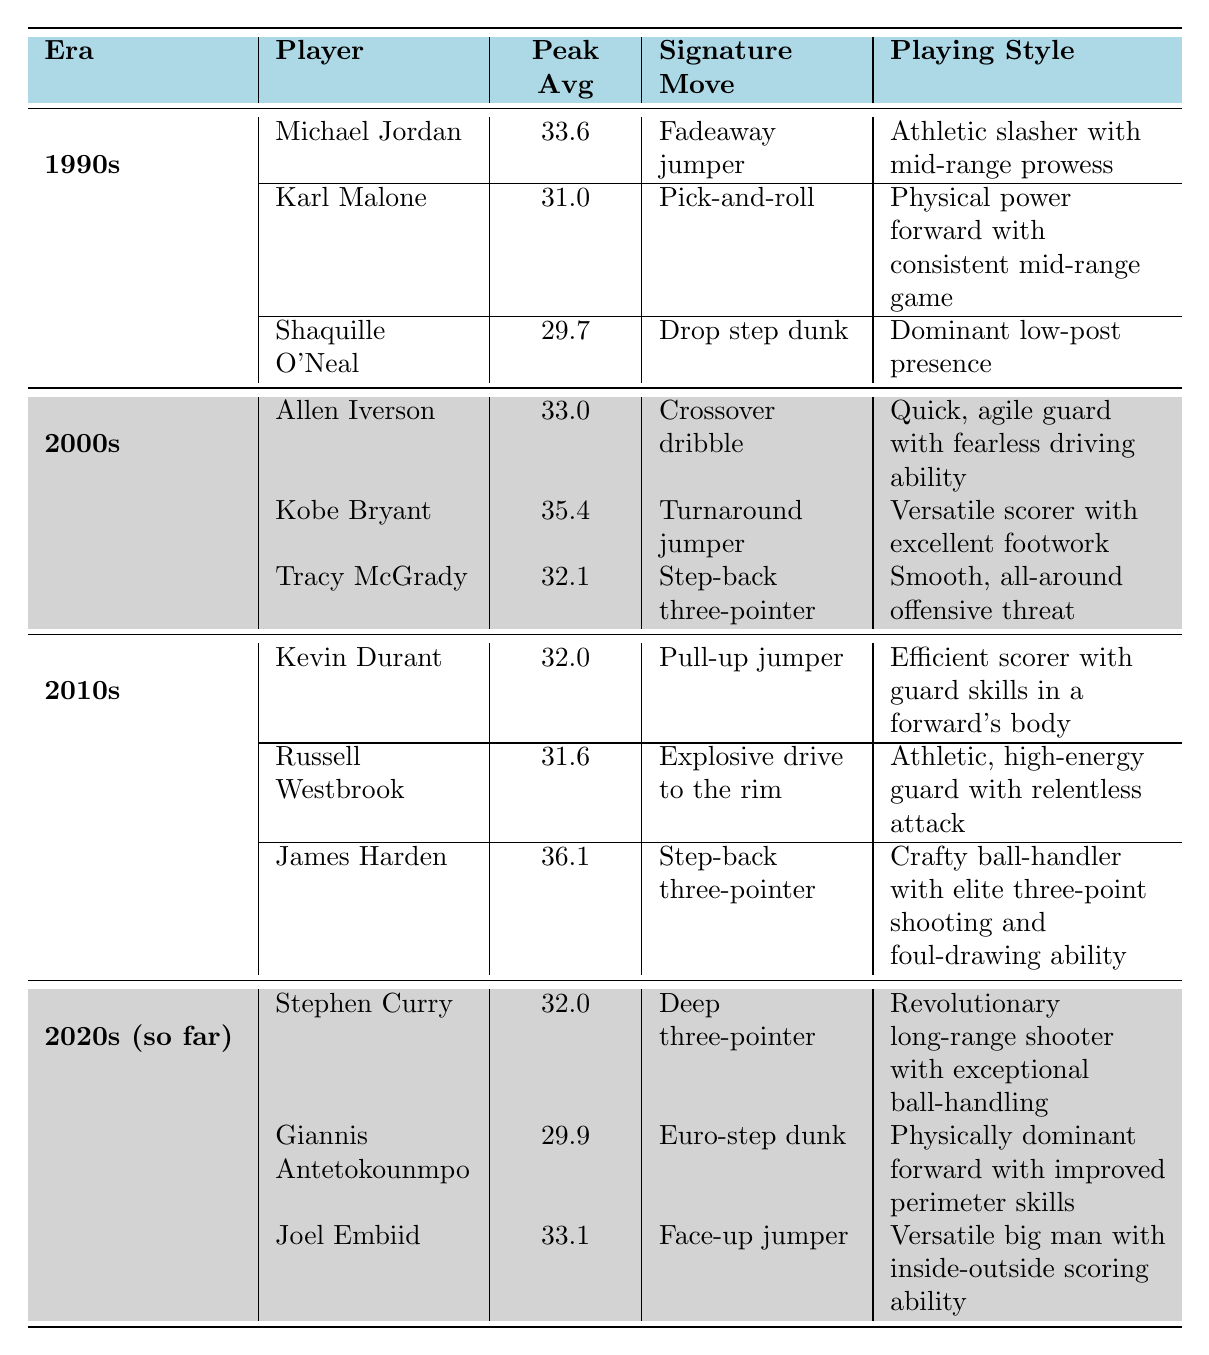What player had the highest peak scoring average in the 2000s? In the 2000s, the peak scoring averages of the top scorers are Allen Iverson (33.0), Kobe Bryant (35.4), and Tracy McGrady (32.1). The highest among these is Kobe Bryant with 35.4.
Answer: 35.4 Which player is known for the "Fadeaway jumper"? The "Fadeaway jumper" is a signature move associated with Michael Jordan, who played in the 1990s.
Answer: Michael Jordan What is the playing style of Kevin Durant? The table states that Kevin Durant's playing style is "Efficient scorer with guard skills in a forward's body".
Answer: Efficient scorer with guard skills in a forward's body How many players had a peak scoring average of over 30 in the 2010s? In the 2010s, the peak scoring averages are: Kevin Durant (32.0), Russell Westbrook (31.6), and James Harden (36.1). All three had averages over 30, which makes it a total of 3 players.
Answer: 3 Is the "Euro-step dunk" associated with a player from the 1990s? The "Euro-step dunk" is listed with Giannis Antetokounmpo, who is from the 2020s era, not the 1990s. Therefore, the statement is false.
Answer: No Which era had the highest peak scoring average player, and who was it? The highest peak scoring average is 36.1 by James Harden, who played in the 2010s. This means the era with the highest individual peak is the 2010s.
Answer: 2010s, James Harden What is the average peak scoring average for players in the 1990s? The peak scoring averages in the 1990s are Michael Jordan (33.6), Karl Malone (31.0), and Shaquille O'Neal (29.7). Adding these gives 94.3, and dividing by 3 gives an average of 31.43.
Answer: 31.43 Which player had a signature move of "Step-back three-pointer"? The "Step-back three-pointer" is noted as a signature move for both Tracy McGrady in the 2000s and James Harden in the 2010s.
Answer: Tracy McGrady, James Harden How does Giannis Antetokounmpo's peak scoring average compare to Shaquille O'Neal's? Giannis Antetokounmpo has a peak scoring average of 29.9 while Shaquille O'Neal had 29.7. Giannis' average is higher by 0.2.
Answer: Giannis is higher by 0.2 Who among the players listed has the lowest peak scoring average, and what is it? In the 1990s, Shaquille O'Neal has the lowest peak scoring average at 29.7 compared to other top scorers in that decade.
Answer: Shaquille O'Neal, 29.7 